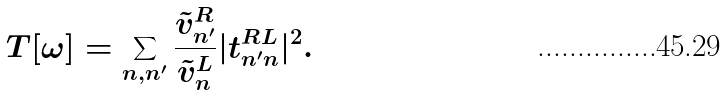Convert formula to latex. <formula><loc_0><loc_0><loc_500><loc_500>T [ \omega ] = \sum _ { n , n ^ { \prime } } \frac { \tilde { v } ^ { R } _ { n ^ { \prime } } } { \tilde { v } ^ { L } _ { n } } | t ^ { R L } _ { n ^ { \prime } n } | ^ { 2 } .</formula> 